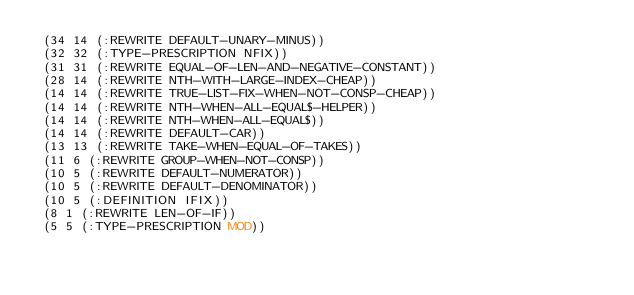Convert code to text. <code><loc_0><loc_0><loc_500><loc_500><_Lisp_> (34 14 (:REWRITE DEFAULT-UNARY-MINUS))
 (32 32 (:TYPE-PRESCRIPTION NFIX))
 (31 31 (:REWRITE EQUAL-OF-LEN-AND-NEGATIVE-CONSTANT))
 (28 14 (:REWRITE NTH-WITH-LARGE-INDEX-CHEAP))
 (14 14 (:REWRITE TRUE-LIST-FIX-WHEN-NOT-CONSP-CHEAP))
 (14 14 (:REWRITE NTH-WHEN-ALL-EQUAL$-HELPER))
 (14 14 (:REWRITE NTH-WHEN-ALL-EQUAL$))
 (14 14 (:REWRITE DEFAULT-CAR))
 (13 13 (:REWRITE TAKE-WHEN-EQUAL-OF-TAKES))
 (11 6 (:REWRITE GROUP-WHEN-NOT-CONSP))
 (10 5 (:REWRITE DEFAULT-NUMERATOR))
 (10 5 (:REWRITE DEFAULT-DENOMINATOR))
 (10 5 (:DEFINITION IFIX))
 (8 1 (:REWRITE LEN-OF-IF))
 (5 5 (:TYPE-PRESCRIPTION MOD))</code> 